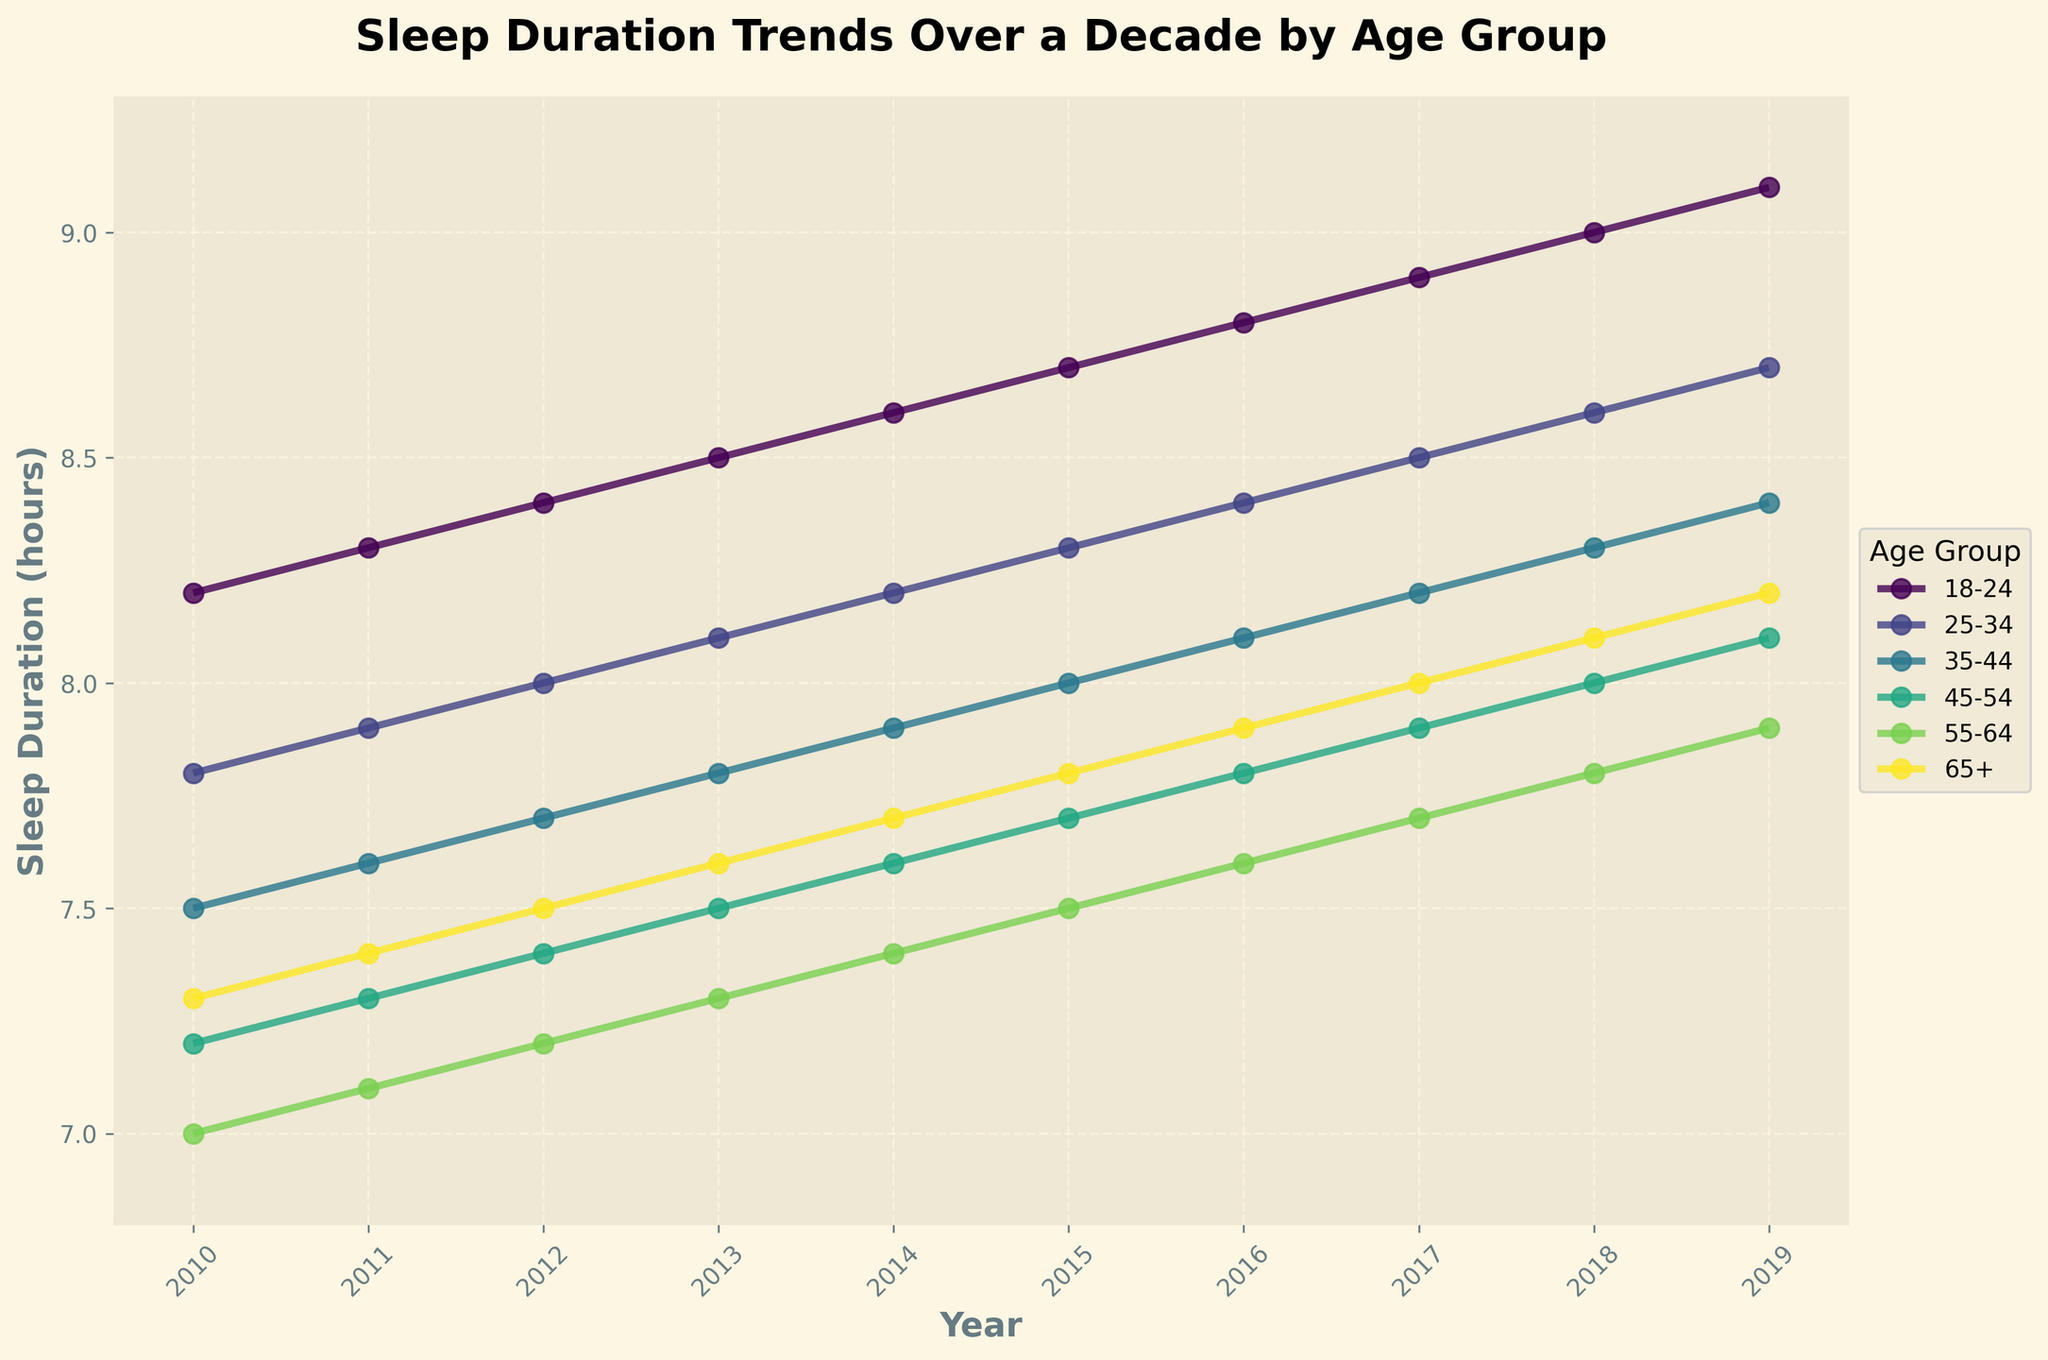Which age group had the highest increase in sleep duration from 2010 to 2019? To find the highest increase, calculate the difference between 2019 and 2010 values for each age group: (1) 18-24: 9.1 - 8.2 = 0.9 (2) 25-34: 8.7 - 7.8 = 0.9 (3) 35-44: 8.4 - 7.5 = 0.9 (4) 45-54: 8.1 - 7.2 = 0.9 (5) 55-64: 7.9 - 7.0 = 0.9 (6) 65+: 8.2 - 7.3 = 0.9. All age groups had the same increase of 0.9 hours.
Answer: All groups had the same increase of 0.9 hours Which age group had the lowest average sleep duration over the decade? Calculate the average sleep duration for each age group over the years: (1) 18-24: (8.2+8.3+8.4+8.5+8.6+8.7+8.8+8.9+9.0+9.1)/10 = 8.65 (2) 25-34: 8.25 (3) 35-44: 7.95 (4) 45-54: 7.6 (5) 55-64: 7.45 (6) 65+: 7.75. Age group 55-64 had the lowest average.
Answer: 55-64 By how much did the sleep duration for the 35-44 age group increase between 2010 and 2015? Find the sleep duration for 35-44 in 2010 (7.5) and in 2015 (8.0). Calculate the difference: 8.0 - 7.5 = 0.5. The increase is 0.5 hours.
Answer: 0.5 Which year had the highest sleep duration for the age group 18-24? Look at the values for the age group 18-24 across the years and identify the highest value. The highest sleep duration is in 2019 (9.1 hours).
Answer: 2019 How does the sleep duration trend for 25-34 compare to that for 45-54 over the decade? Both age groups show a consistent upward trend. For 25-34, it starts at 7.8 and ends at 8.7; for 45-54, it starts at 7.2 and ends at 8.1. Both age groups increase by 0.9 hours, showing a similar upward trend.
Answer: Similar upward trend What is the overall trend in sleep duration for age group 65+ from 2010 to 2019? Observe the values for age group 65+ from 2010 (7.3) to 2019 (8.2). The trend is consistently upward, indicating an increase over the decade.
Answer: Upward trend Which age group showed the most consistent increase in sleep duration over the decade? Each age group's line can be analyzed for consistency in slope. All groups show a consistent gradual increase year by year. Detailing the consistency without dips or flat phases reveals no age group had significant deviations. Therefore, all age groups show a consistently increasing trend.
Answer: All groups Compare the sleep duration in 2015 for age groups 25-34 and 55-64. Locate the values in 2015 for both age groups: 25-34 is 8.3 and 55-64 is 7.5. Comparatively, 25-34 group’s sleep duration is higher by 0.8 hours.
Answer: 25-34 is higher by 0.8 hours 